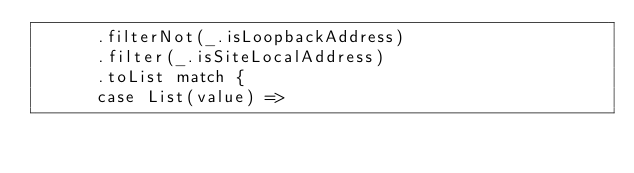Convert code to text. <code><loc_0><loc_0><loc_500><loc_500><_Scala_>      .filterNot(_.isLoopbackAddress)
      .filter(_.isSiteLocalAddress)
      .toList match {
      case List(value) =></code> 